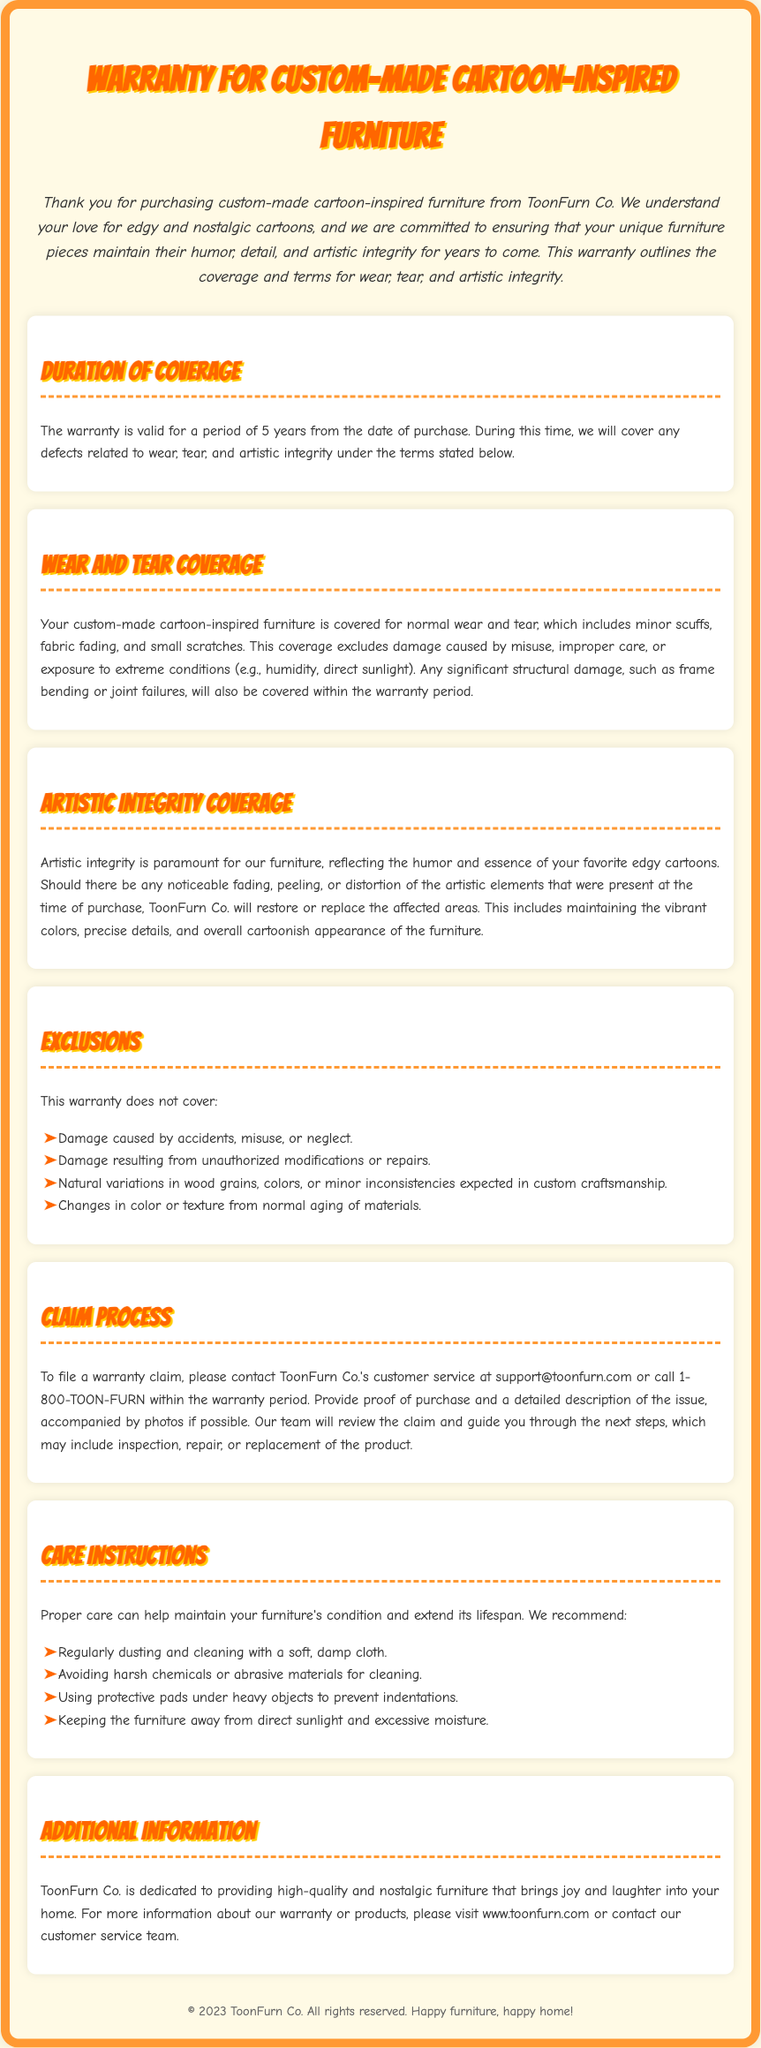What is the duration of coverage? The warranty is valid for a period of 5 years from the date of purchase.
Answer: 5 years What types of damage are covered under wear and tear? Normal wear and tear includes minor scuffs, fabric fading, and small scratches, with exclusions for misuse or extremes.
Answer: Minor scuffs, fabric fading, small scratches What does artistic integrity coverage include? Artistic integrity coverage includes restoring or replacing noticeable fading, peeling, or distortion of artistic elements.
Answer: Noticeable fading, peeling, distortion What is excluded from the warranty? The warranty does not cover damage caused by accidents, misuse, or neglect, among other exclusions.
Answer: Accidents, misuse, neglect How can a claim be filed? To file a warranty claim, contact customer service at support@toonfurn.com or call 1-800-TOON-FURN.
Answer: Email or call customer service What is the recommended cleaning method for the furniture? We recommend regularly dusting and cleaning with a soft, damp cloth.
Answer: Soft, damp cloth What should be avoided to protect the furniture? Avoid harsh chemicals or abrasive materials for cleaning.
Answer: Harsh chemicals What maintains the furniture's artistic integrity? Maintaining vibrant colors, precise details, and overall cartoonish appearance is essential.
Answer: Vibrant colors, precise details What is the website for more information? For more information about the warranty or products, visit www.toonfurn.com.
Answer: www.toonfurn.com 